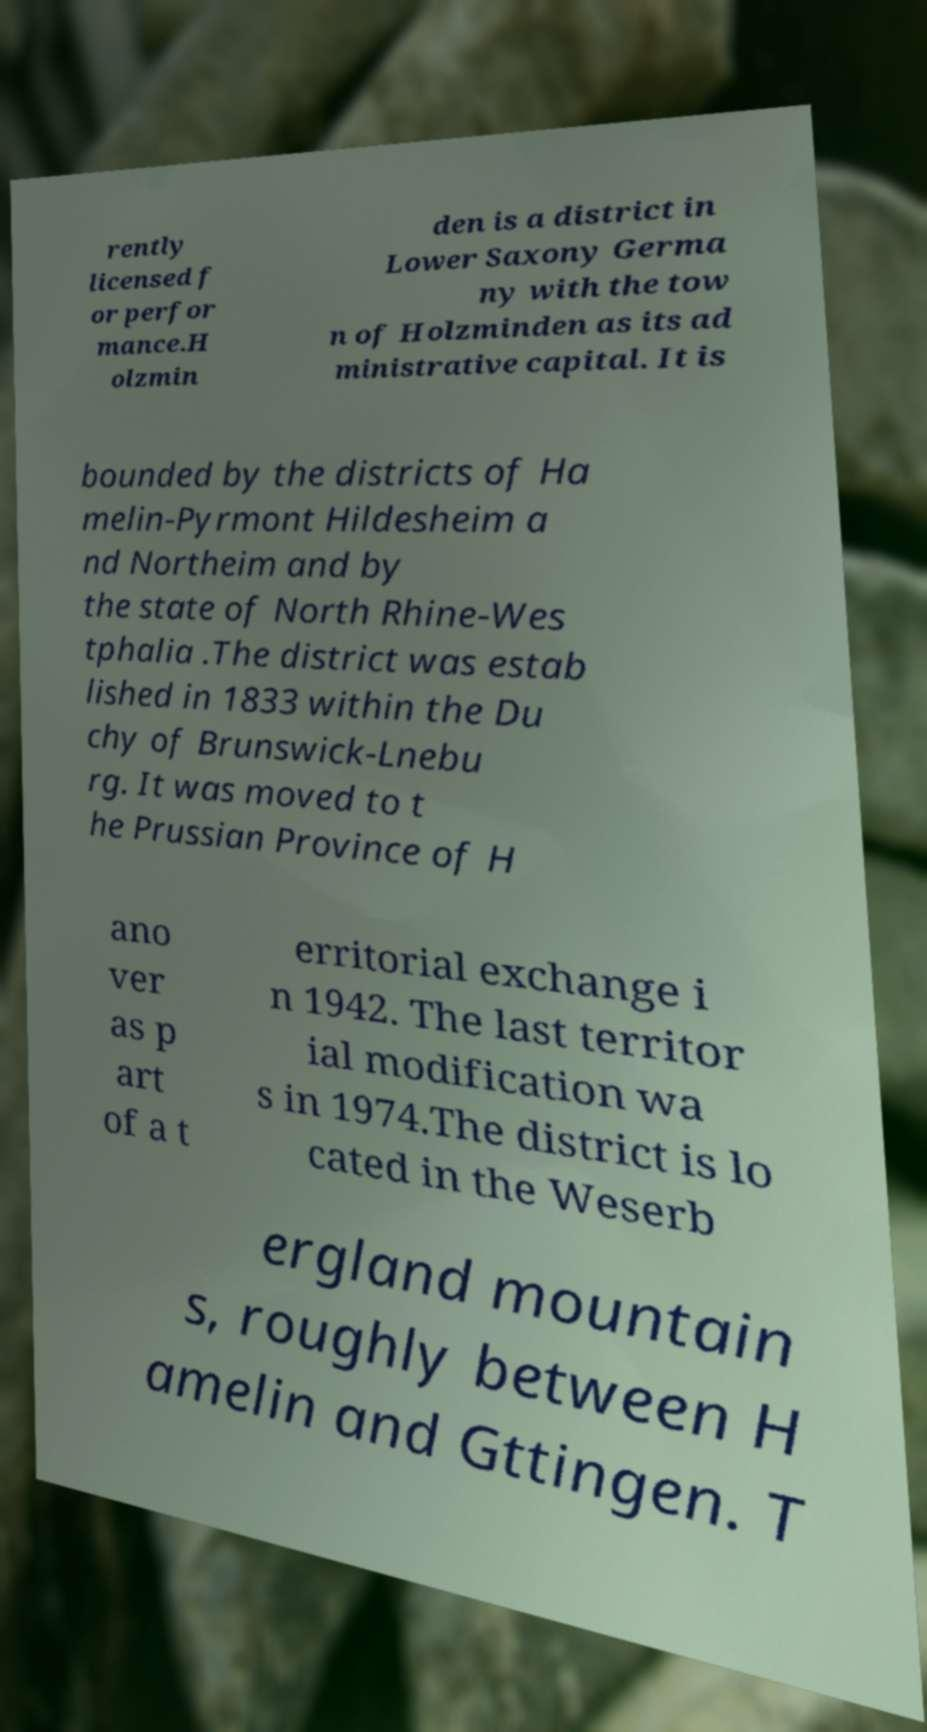Please read and relay the text visible in this image. What does it say? rently licensed f or perfor mance.H olzmin den is a district in Lower Saxony Germa ny with the tow n of Holzminden as its ad ministrative capital. It is bounded by the districts of Ha melin-Pyrmont Hildesheim a nd Northeim and by the state of North Rhine-Wes tphalia .The district was estab lished in 1833 within the Du chy of Brunswick-Lnebu rg. It was moved to t he Prussian Province of H ano ver as p art of a t erritorial exchange i n 1942. The last territor ial modification wa s in 1974.The district is lo cated in the Weserb ergland mountain s, roughly between H amelin and Gttingen. T 